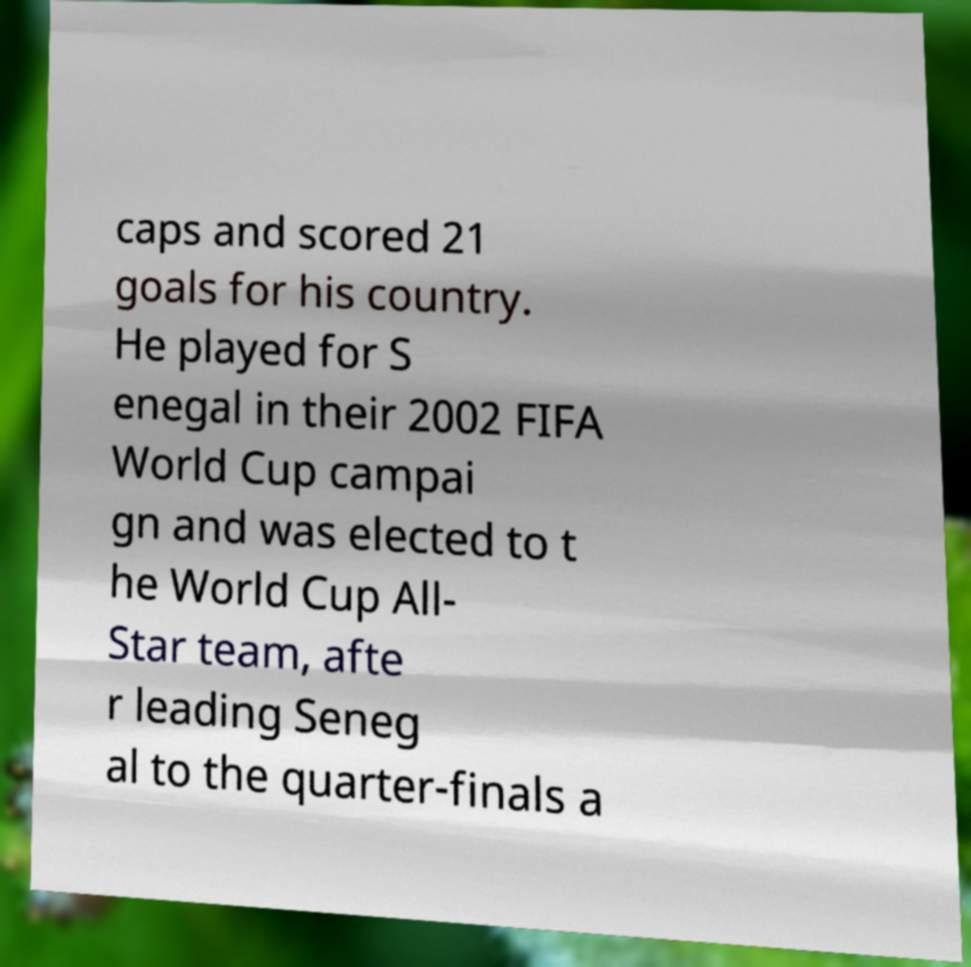I need the written content from this picture converted into text. Can you do that? caps and scored 21 goals for his country. He played for S enegal in their 2002 FIFA World Cup campai gn and was elected to t he World Cup All- Star team, afte r leading Seneg al to the quarter-finals a 